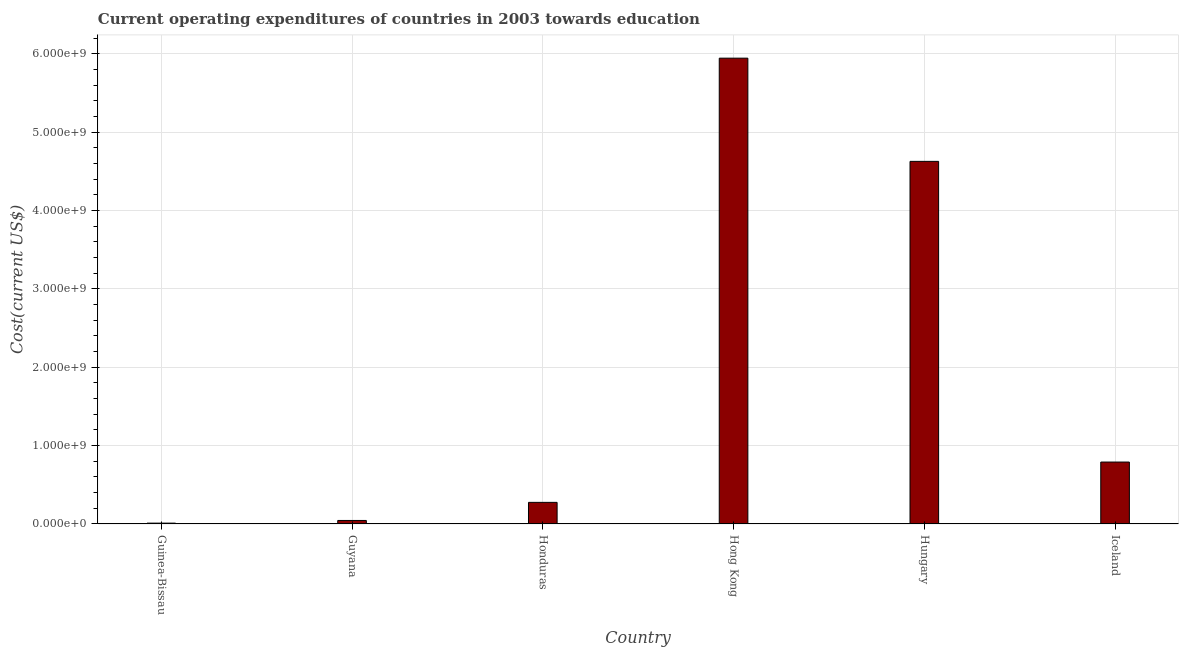Does the graph contain any zero values?
Offer a very short reply. No. What is the title of the graph?
Ensure brevity in your answer.  Current operating expenditures of countries in 2003 towards education. What is the label or title of the Y-axis?
Keep it short and to the point. Cost(current US$). What is the education expenditure in Guyana?
Give a very brief answer. 4.49e+07. Across all countries, what is the maximum education expenditure?
Ensure brevity in your answer.  5.94e+09. Across all countries, what is the minimum education expenditure?
Your response must be concise. 1.07e+07. In which country was the education expenditure maximum?
Keep it short and to the point. Hong Kong. In which country was the education expenditure minimum?
Make the answer very short. Guinea-Bissau. What is the sum of the education expenditure?
Your answer should be very brief. 1.17e+1. What is the difference between the education expenditure in Guinea-Bissau and Guyana?
Make the answer very short. -3.42e+07. What is the average education expenditure per country?
Keep it short and to the point. 1.95e+09. What is the median education expenditure?
Offer a very short reply. 5.33e+08. In how many countries, is the education expenditure greater than 2200000000 US$?
Make the answer very short. 2. What is the ratio of the education expenditure in Guinea-Bissau to that in Honduras?
Keep it short and to the point. 0.04. Is the education expenditure in Hungary less than that in Iceland?
Your answer should be compact. No. Is the difference between the education expenditure in Honduras and Hong Kong greater than the difference between any two countries?
Your answer should be compact. No. What is the difference between the highest and the second highest education expenditure?
Provide a succinct answer. 1.32e+09. What is the difference between the highest and the lowest education expenditure?
Offer a terse response. 5.93e+09. In how many countries, is the education expenditure greater than the average education expenditure taken over all countries?
Keep it short and to the point. 2. Are all the bars in the graph horizontal?
Give a very brief answer. No. What is the difference between two consecutive major ticks on the Y-axis?
Ensure brevity in your answer.  1.00e+09. Are the values on the major ticks of Y-axis written in scientific E-notation?
Offer a very short reply. Yes. What is the Cost(current US$) of Guinea-Bissau?
Ensure brevity in your answer.  1.07e+07. What is the Cost(current US$) in Guyana?
Your answer should be very brief. 4.49e+07. What is the Cost(current US$) in Honduras?
Offer a very short reply. 2.76e+08. What is the Cost(current US$) in Hong Kong?
Your answer should be very brief. 5.94e+09. What is the Cost(current US$) in Hungary?
Your answer should be very brief. 4.63e+09. What is the Cost(current US$) in Iceland?
Keep it short and to the point. 7.90e+08. What is the difference between the Cost(current US$) in Guinea-Bissau and Guyana?
Ensure brevity in your answer.  -3.42e+07. What is the difference between the Cost(current US$) in Guinea-Bissau and Honduras?
Provide a succinct answer. -2.65e+08. What is the difference between the Cost(current US$) in Guinea-Bissau and Hong Kong?
Ensure brevity in your answer.  -5.93e+09. What is the difference between the Cost(current US$) in Guinea-Bissau and Hungary?
Offer a terse response. -4.62e+09. What is the difference between the Cost(current US$) in Guinea-Bissau and Iceland?
Offer a terse response. -7.79e+08. What is the difference between the Cost(current US$) in Guyana and Honduras?
Offer a very short reply. -2.31e+08. What is the difference between the Cost(current US$) in Guyana and Hong Kong?
Your answer should be compact. -5.90e+09. What is the difference between the Cost(current US$) in Guyana and Hungary?
Keep it short and to the point. -4.58e+09. What is the difference between the Cost(current US$) in Guyana and Iceland?
Provide a short and direct response. -7.45e+08. What is the difference between the Cost(current US$) in Honduras and Hong Kong?
Your response must be concise. -5.67e+09. What is the difference between the Cost(current US$) in Honduras and Hungary?
Offer a very short reply. -4.35e+09. What is the difference between the Cost(current US$) in Honduras and Iceland?
Make the answer very short. -5.14e+08. What is the difference between the Cost(current US$) in Hong Kong and Hungary?
Offer a very short reply. 1.32e+09. What is the difference between the Cost(current US$) in Hong Kong and Iceland?
Your answer should be very brief. 5.15e+09. What is the difference between the Cost(current US$) in Hungary and Iceland?
Keep it short and to the point. 3.84e+09. What is the ratio of the Cost(current US$) in Guinea-Bissau to that in Guyana?
Provide a succinct answer. 0.24. What is the ratio of the Cost(current US$) in Guinea-Bissau to that in Honduras?
Ensure brevity in your answer.  0.04. What is the ratio of the Cost(current US$) in Guinea-Bissau to that in Hong Kong?
Make the answer very short. 0. What is the ratio of the Cost(current US$) in Guinea-Bissau to that in Hungary?
Make the answer very short. 0. What is the ratio of the Cost(current US$) in Guinea-Bissau to that in Iceland?
Make the answer very short. 0.01. What is the ratio of the Cost(current US$) in Guyana to that in Honduras?
Ensure brevity in your answer.  0.16. What is the ratio of the Cost(current US$) in Guyana to that in Hong Kong?
Offer a terse response. 0.01. What is the ratio of the Cost(current US$) in Guyana to that in Iceland?
Your answer should be compact. 0.06. What is the ratio of the Cost(current US$) in Honduras to that in Hong Kong?
Make the answer very short. 0.05. What is the ratio of the Cost(current US$) in Honduras to that in Iceland?
Your response must be concise. 0.35. What is the ratio of the Cost(current US$) in Hong Kong to that in Hungary?
Your response must be concise. 1.28. What is the ratio of the Cost(current US$) in Hong Kong to that in Iceland?
Your answer should be very brief. 7.52. What is the ratio of the Cost(current US$) in Hungary to that in Iceland?
Ensure brevity in your answer.  5.86. 